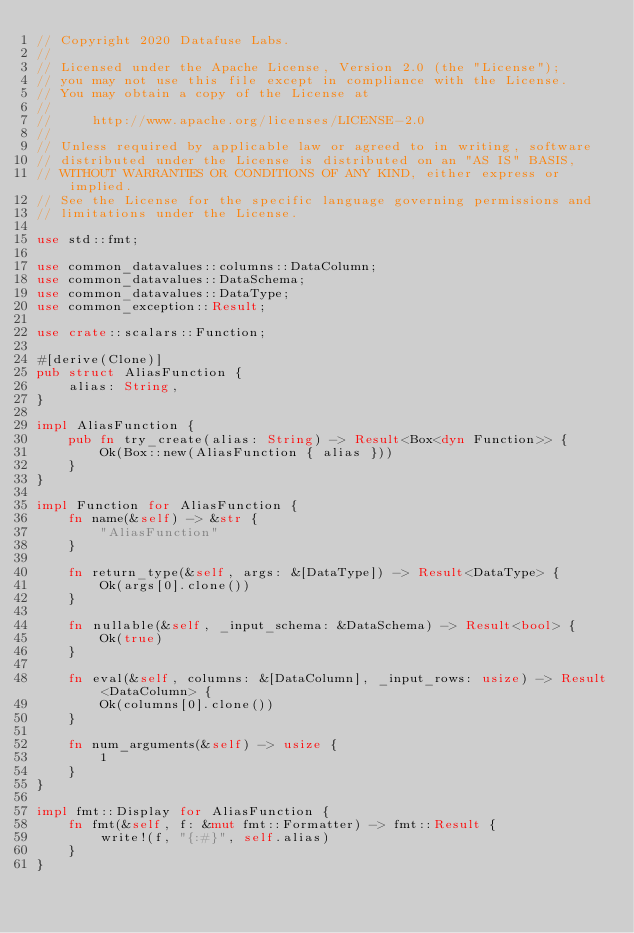<code> <loc_0><loc_0><loc_500><loc_500><_Rust_>// Copyright 2020 Datafuse Labs.
//
// Licensed under the Apache License, Version 2.0 (the "License");
// you may not use this file except in compliance with the License.
// You may obtain a copy of the License at
//
//     http://www.apache.org/licenses/LICENSE-2.0
//
// Unless required by applicable law or agreed to in writing, software
// distributed under the License is distributed on an "AS IS" BASIS,
// WITHOUT WARRANTIES OR CONDITIONS OF ANY KIND, either express or implied.
// See the License for the specific language governing permissions and
// limitations under the License.

use std::fmt;

use common_datavalues::columns::DataColumn;
use common_datavalues::DataSchema;
use common_datavalues::DataType;
use common_exception::Result;

use crate::scalars::Function;

#[derive(Clone)]
pub struct AliasFunction {
    alias: String,
}

impl AliasFunction {
    pub fn try_create(alias: String) -> Result<Box<dyn Function>> {
        Ok(Box::new(AliasFunction { alias }))
    }
}

impl Function for AliasFunction {
    fn name(&self) -> &str {
        "AliasFunction"
    }

    fn return_type(&self, args: &[DataType]) -> Result<DataType> {
        Ok(args[0].clone())
    }

    fn nullable(&self, _input_schema: &DataSchema) -> Result<bool> {
        Ok(true)
    }

    fn eval(&self, columns: &[DataColumn], _input_rows: usize) -> Result<DataColumn> {
        Ok(columns[0].clone())
    }

    fn num_arguments(&self) -> usize {
        1
    }
}

impl fmt::Display for AliasFunction {
    fn fmt(&self, f: &mut fmt::Formatter) -> fmt::Result {
        write!(f, "{:#}", self.alias)
    }
}
</code> 